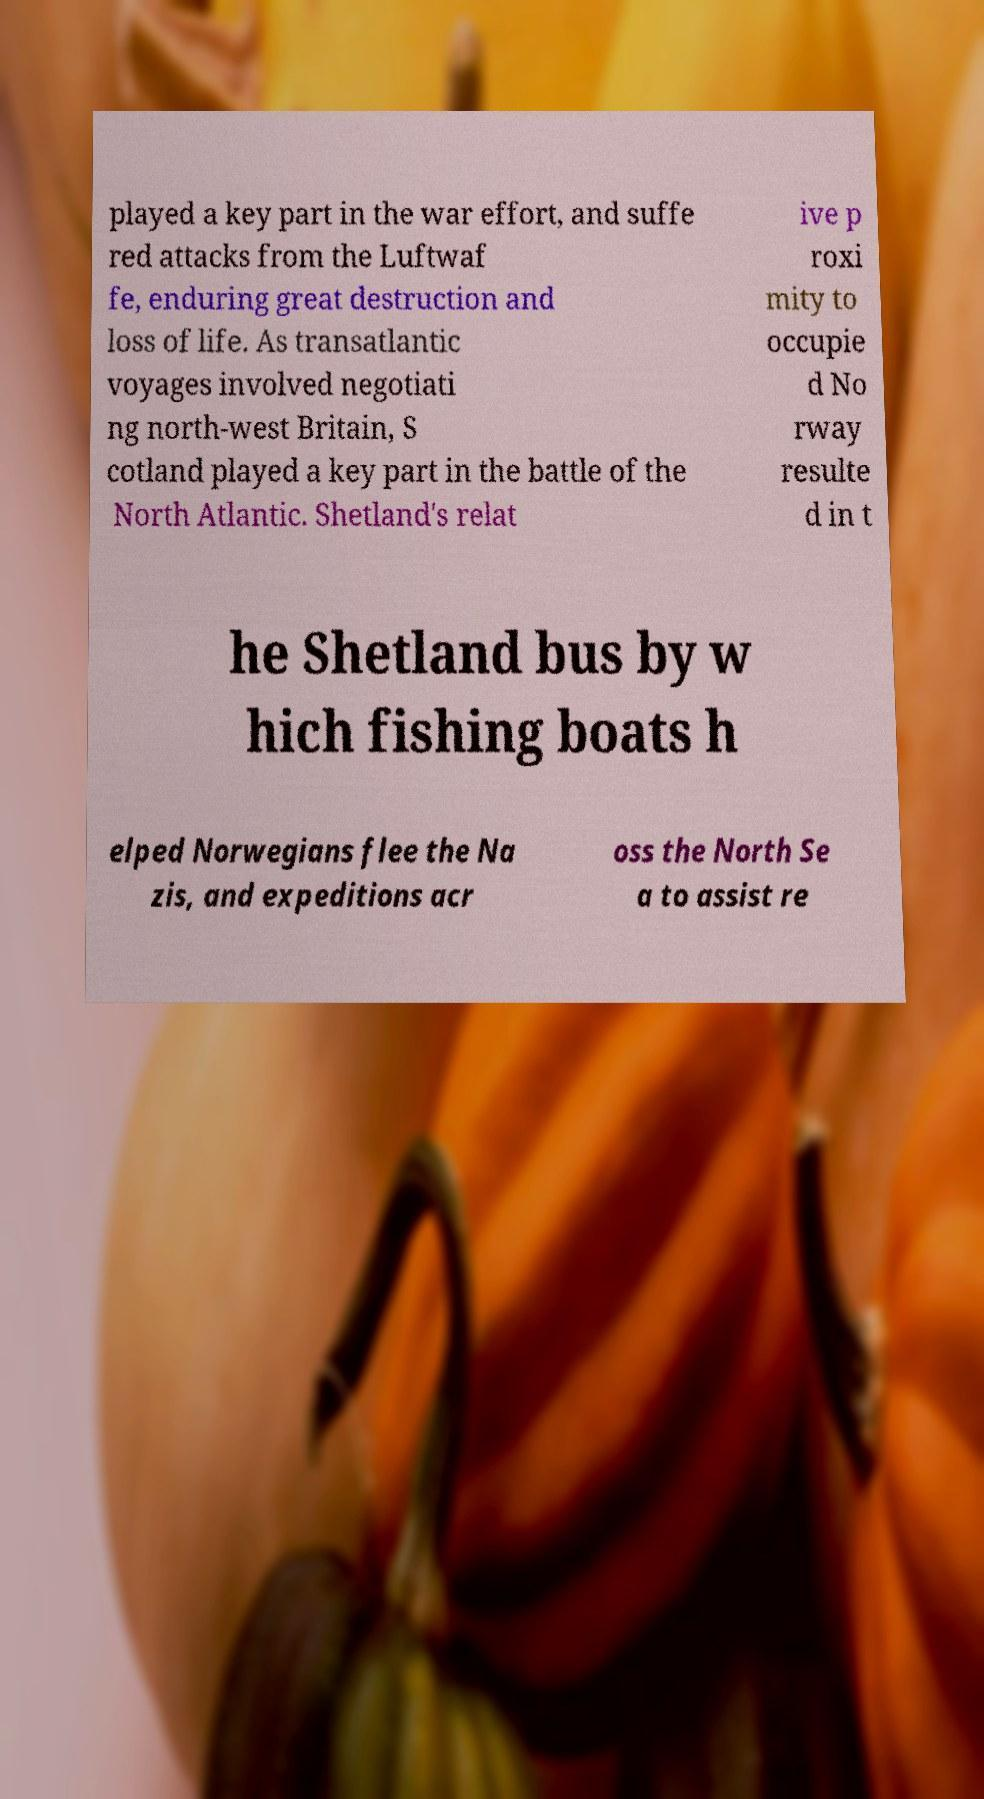There's text embedded in this image that I need extracted. Can you transcribe it verbatim? played a key part in the war effort, and suffe red attacks from the Luftwaf fe, enduring great destruction and loss of life. As transatlantic voyages involved negotiati ng north-west Britain, S cotland played a key part in the battle of the North Atlantic. Shetland's relat ive p roxi mity to occupie d No rway resulte d in t he Shetland bus by w hich fishing boats h elped Norwegians flee the Na zis, and expeditions acr oss the North Se a to assist re 